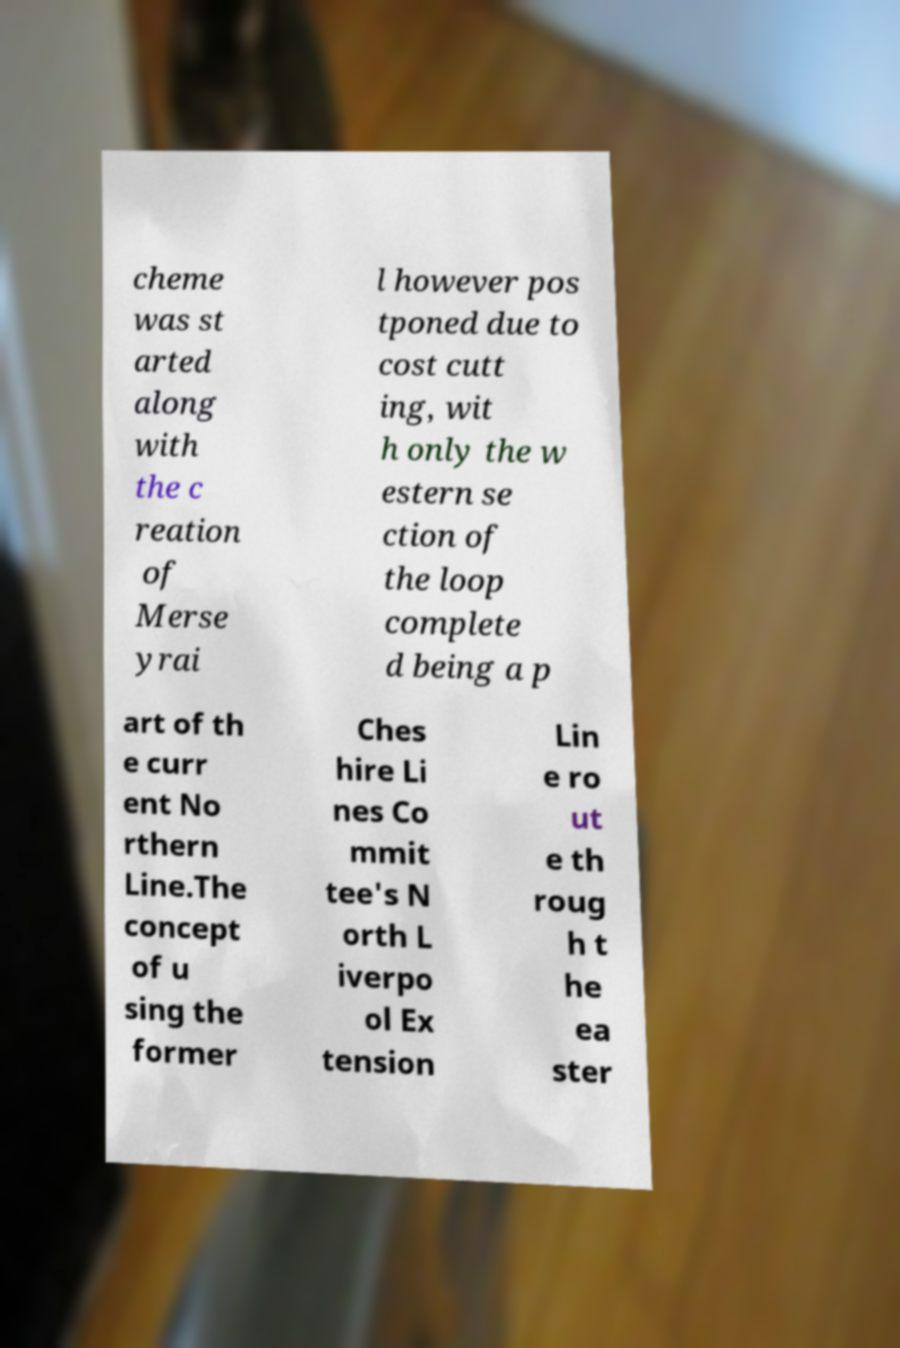Can you accurately transcribe the text from the provided image for me? cheme was st arted along with the c reation of Merse yrai l however pos tponed due to cost cutt ing, wit h only the w estern se ction of the loop complete d being a p art of th e curr ent No rthern Line.The concept of u sing the former Ches hire Li nes Co mmit tee's N orth L iverpo ol Ex tension Lin e ro ut e th roug h t he ea ster 